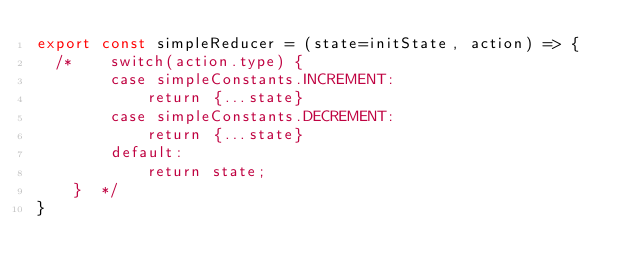<code> <loc_0><loc_0><loc_500><loc_500><_JavaScript_>export const simpleReducer = (state=initState, action) => {
  /*    switch(action.type) {
        case simpleConstants.INCREMENT:
            return {...state}
        case simpleConstants.DECREMENT:
            return {...state}
        default:
            return state;
    }  */
}
</code> 